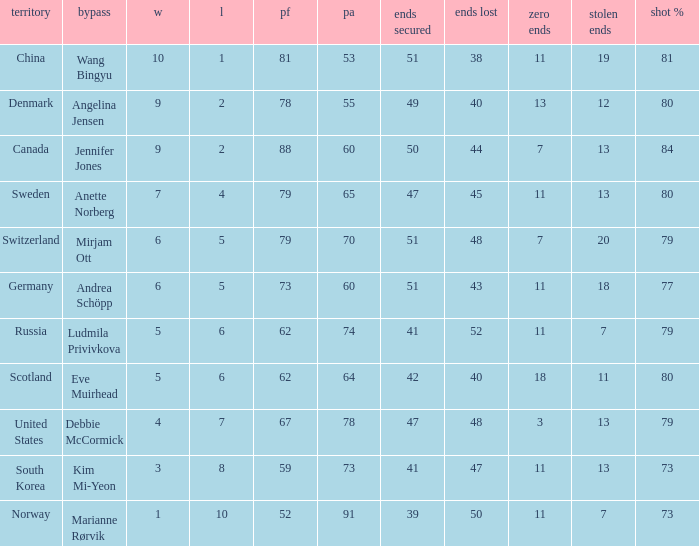Andrea Schöpp is the skip of which country? Germany. 